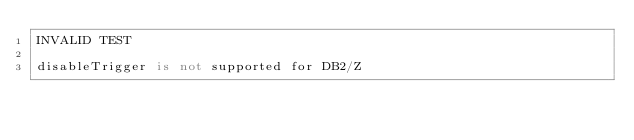<code> <loc_0><loc_0><loc_500><loc_500><_SQL_>INVALID TEST

disableTrigger is not supported for DB2/Z</code> 